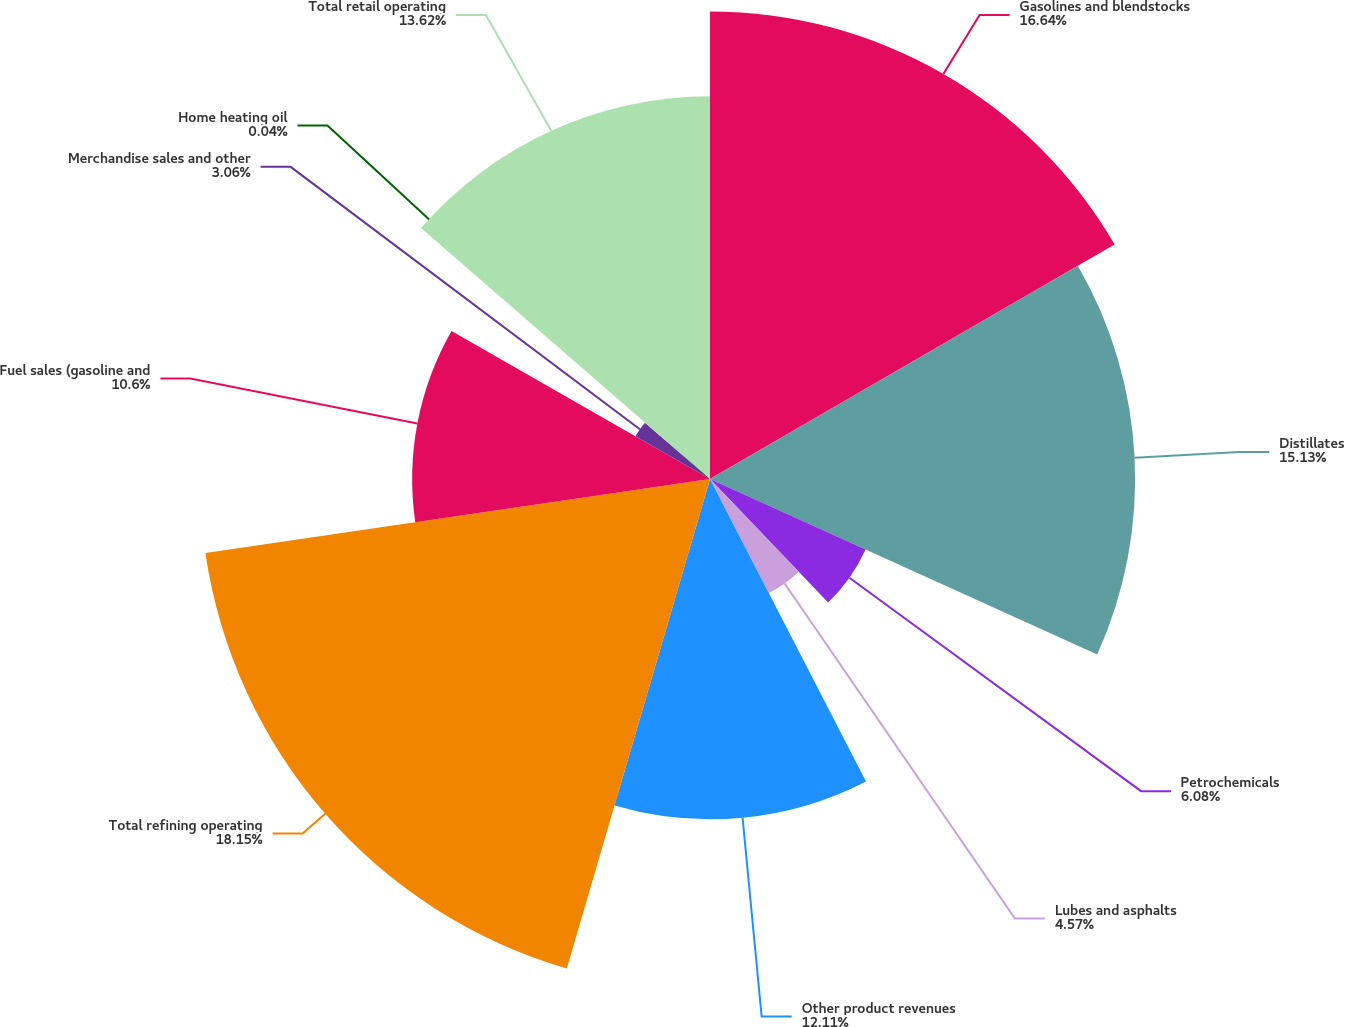Convert chart to OTSL. <chart><loc_0><loc_0><loc_500><loc_500><pie_chart><fcel>Gasolines and blendstocks<fcel>Distillates<fcel>Petrochemicals<fcel>Lubes and asphalts<fcel>Other product revenues<fcel>Total refining operating<fcel>Fuel sales (gasoline and<fcel>Merchandise sales and other<fcel>Home heating oil<fcel>Total retail operating<nl><fcel>16.64%<fcel>15.13%<fcel>6.08%<fcel>4.57%<fcel>12.11%<fcel>18.15%<fcel>10.6%<fcel>3.06%<fcel>0.04%<fcel>13.62%<nl></chart> 